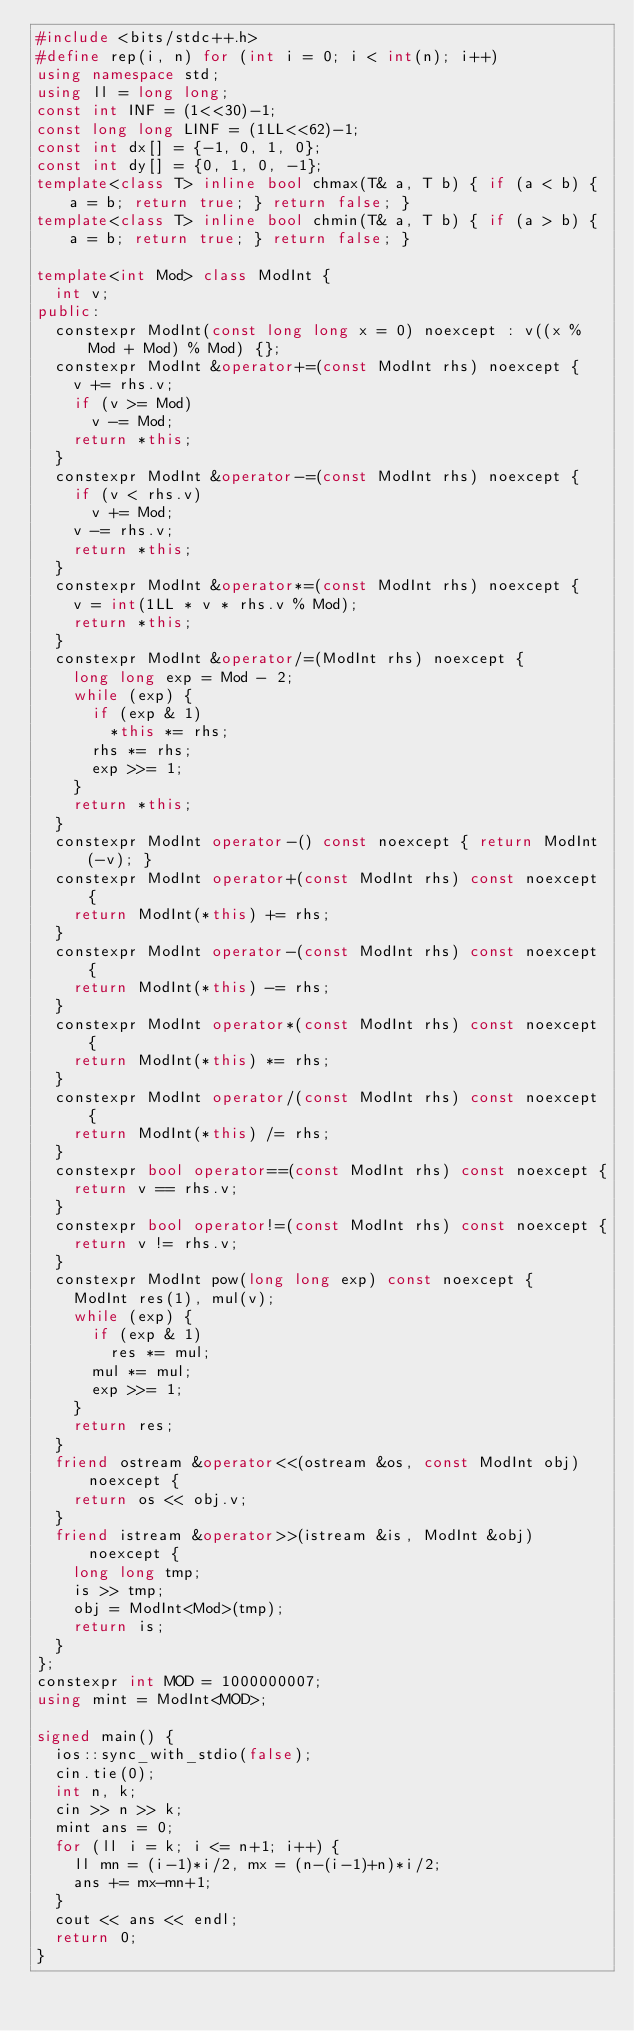<code> <loc_0><loc_0><loc_500><loc_500><_C++_>#include <bits/stdc++.h>
#define rep(i, n) for (int i = 0; i < int(n); i++)
using namespace std;
using ll = long long;
const int INF = (1<<30)-1;
const long long LINF = (1LL<<62)-1;
const int dx[] = {-1, 0, 1, 0};
const int dy[] = {0, 1, 0, -1};
template<class T> inline bool chmax(T& a, T b) { if (a < b) { a = b; return true; } return false; }
template<class T> inline bool chmin(T& a, T b) { if (a > b) { a = b; return true; } return false; }

template<int Mod> class ModInt {
  int v;
public:
  constexpr ModInt(const long long x = 0) noexcept : v((x % Mod + Mod) % Mod) {};
  constexpr ModInt &operator+=(const ModInt rhs) noexcept {
    v += rhs.v;
    if (v >= Mod)
      v -= Mod;
    return *this;
  }
  constexpr ModInt &operator-=(const ModInt rhs) noexcept {
    if (v < rhs.v)
      v += Mod;
    v -= rhs.v;
    return *this;
  }
  constexpr ModInt &operator*=(const ModInt rhs) noexcept {
    v = int(1LL * v * rhs.v % Mod);
    return *this;
  }
  constexpr ModInt &operator/=(ModInt rhs) noexcept {
    long long exp = Mod - 2;
    while (exp) {
      if (exp & 1)
        *this *= rhs;
      rhs *= rhs;
      exp >>= 1;
    }
    return *this;
  }
  constexpr ModInt operator-() const noexcept { return ModInt(-v); }
  constexpr ModInt operator+(const ModInt rhs) const noexcept {
    return ModInt(*this) += rhs;
  }
  constexpr ModInt operator-(const ModInt rhs) const noexcept {
    return ModInt(*this) -= rhs;
  }
  constexpr ModInt operator*(const ModInt rhs) const noexcept {
    return ModInt(*this) *= rhs;
  }
  constexpr ModInt operator/(const ModInt rhs) const noexcept {
    return ModInt(*this) /= rhs;
  }
  constexpr bool operator==(const ModInt rhs) const noexcept {
    return v == rhs.v;
  }
  constexpr bool operator!=(const ModInt rhs) const noexcept {
    return v != rhs.v;
  }
  constexpr ModInt pow(long long exp) const noexcept {
    ModInt res(1), mul(v);
    while (exp) {
      if (exp & 1)
        res *= mul;
      mul *= mul;
      exp >>= 1;
    }
    return res;
  }
  friend ostream &operator<<(ostream &os, const ModInt obj) noexcept {
    return os << obj.v;
  }
  friend istream &operator>>(istream &is, ModInt &obj) noexcept {
    long long tmp;
    is >> tmp;
    obj = ModInt<Mod>(tmp);
    return is;
  }
};
constexpr int MOD = 1000000007;
using mint = ModInt<MOD>;

signed main() {
  ios::sync_with_stdio(false);
  cin.tie(0);
  int n, k;
  cin >> n >> k;
  mint ans = 0;
  for (ll i = k; i <= n+1; i++) {
    ll mn = (i-1)*i/2, mx = (n-(i-1)+n)*i/2;
    ans += mx-mn+1;
  }
  cout << ans << endl;
  return 0;
}</code> 